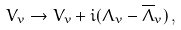Convert formula to latex. <formula><loc_0><loc_0><loc_500><loc_500>V _ { v } \rightarrow V _ { v } + i ( \Lambda _ { v } - \overline { \Lambda } _ { v } ) \, ,</formula> 